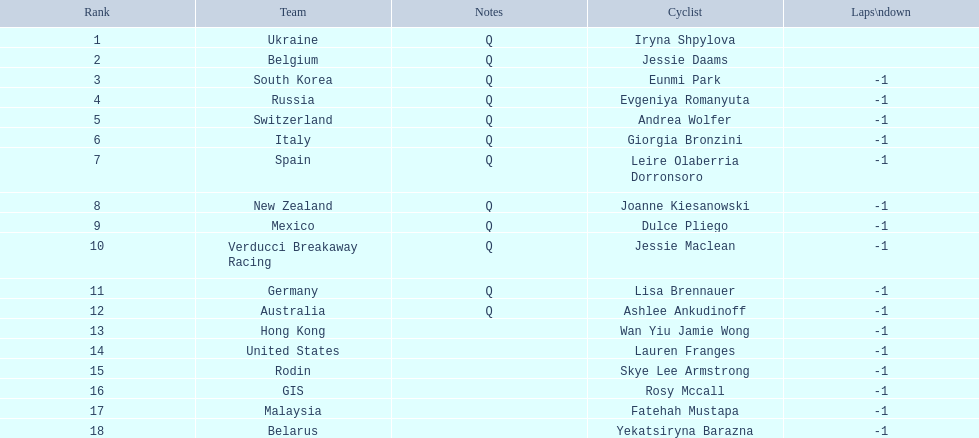Who are all the cyclists? Iryna Shpylova, Jessie Daams, Eunmi Park, Evgeniya Romanyuta, Andrea Wolfer, Giorgia Bronzini, Leire Olaberria Dorronsoro, Joanne Kiesanowski, Dulce Pliego, Jessie Maclean, Lisa Brennauer, Ashlee Ankudinoff, Wan Yiu Jamie Wong, Lauren Franges, Skye Lee Armstrong, Rosy Mccall, Fatehah Mustapa, Yekatsiryna Barazna. What were their ranks? 1, 2, 3, 4, 5, 6, 7, 8, 9, 10, 11, 12, 13, 14, 15, 16, 17, 18. Who was ranked highest? Iryna Shpylova. 